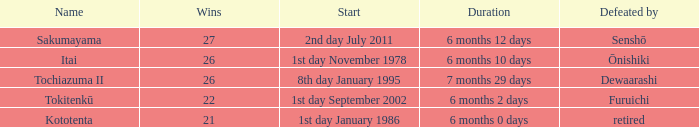How many wins, on average, were defeated by furuichi? 22.0. 